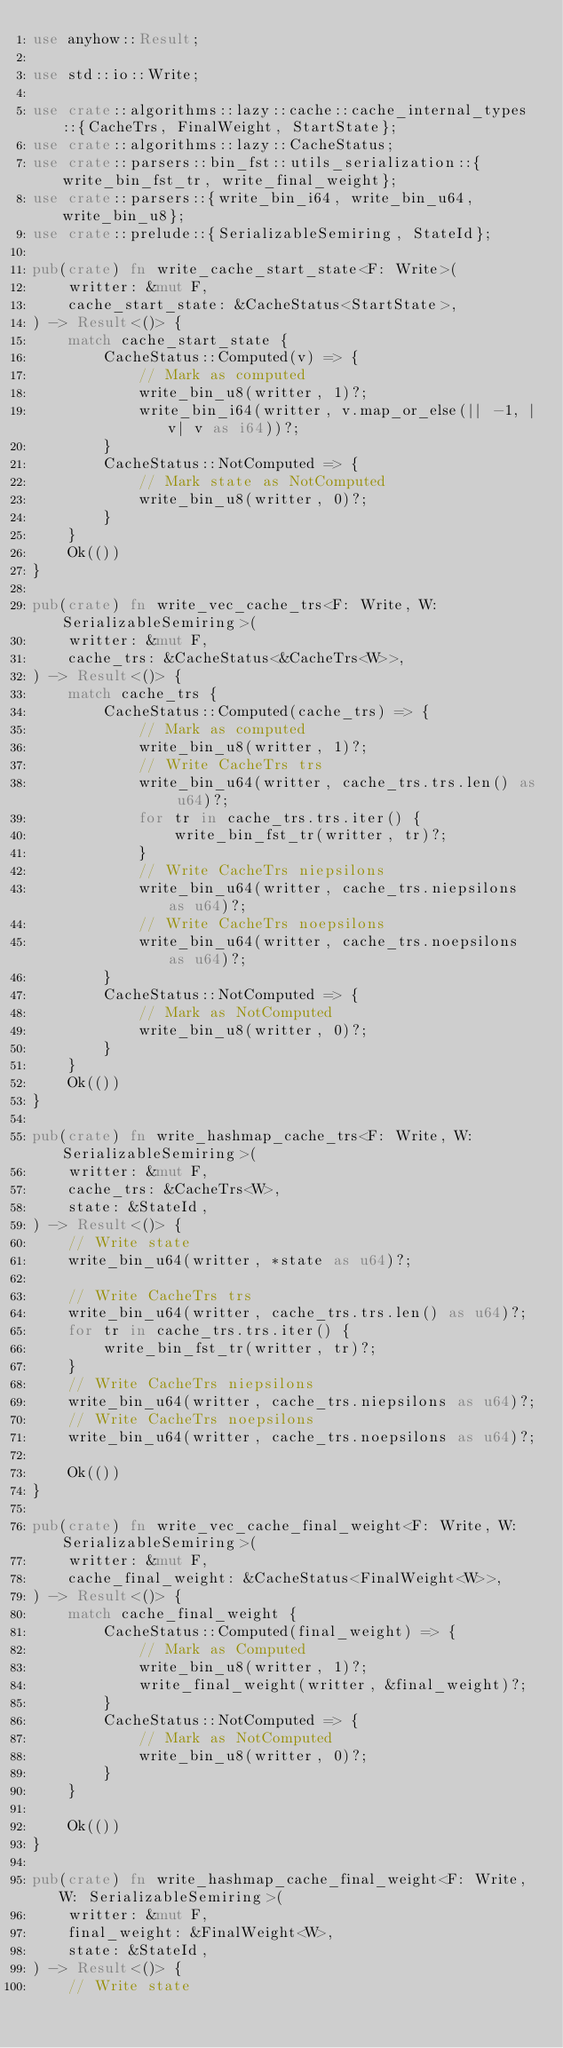<code> <loc_0><loc_0><loc_500><loc_500><_Rust_>use anyhow::Result;

use std::io::Write;

use crate::algorithms::lazy::cache::cache_internal_types::{CacheTrs, FinalWeight, StartState};
use crate::algorithms::lazy::CacheStatus;
use crate::parsers::bin_fst::utils_serialization::{write_bin_fst_tr, write_final_weight};
use crate::parsers::{write_bin_i64, write_bin_u64, write_bin_u8};
use crate::prelude::{SerializableSemiring, StateId};

pub(crate) fn write_cache_start_state<F: Write>(
    writter: &mut F,
    cache_start_state: &CacheStatus<StartState>,
) -> Result<()> {
    match cache_start_state {
        CacheStatus::Computed(v) => {
            // Mark as computed
            write_bin_u8(writter, 1)?;
            write_bin_i64(writter, v.map_or_else(|| -1, |v| v as i64))?;
        }
        CacheStatus::NotComputed => {
            // Mark state as NotComputed
            write_bin_u8(writter, 0)?;
        }
    }
    Ok(())
}

pub(crate) fn write_vec_cache_trs<F: Write, W: SerializableSemiring>(
    writter: &mut F,
    cache_trs: &CacheStatus<&CacheTrs<W>>,
) -> Result<()> {
    match cache_trs {
        CacheStatus::Computed(cache_trs) => {
            // Mark as computed
            write_bin_u8(writter, 1)?;
            // Write CacheTrs trs
            write_bin_u64(writter, cache_trs.trs.len() as u64)?;
            for tr in cache_trs.trs.iter() {
                write_bin_fst_tr(writter, tr)?;
            }
            // Write CacheTrs niepsilons
            write_bin_u64(writter, cache_trs.niepsilons as u64)?;
            // Write CacheTrs noepsilons
            write_bin_u64(writter, cache_trs.noepsilons as u64)?;
        }
        CacheStatus::NotComputed => {
            // Mark as NotComputed
            write_bin_u8(writter, 0)?;
        }
    }
    Ok(())
}

pub(crate) fn write_hashmap_cache_trs<F: Write, W: SerializableSemiring>(
    writter: &mut F,
    cache_trs: &CacheTrs<W>,
    state: &StateId,
) -> Result<()> {
    // Write state
    write_bin_u64(writter, *state as u64)?;

    // Write CacheTrs trs
    write_bin_u64(writter, cache_trs.trs.len() as u64)?;
    for tr in cache_trs.trs.iter() {
        write_bin_fst_tr(writter, tr)?;
    }
    // Write CacheTrs niepsilons
    write_bin_u64(writter, cache_trs.niepsilons as u64)?;
    // Write CacheTrs noepsilons
    write_bin_u64(writter, cache_trs.noepsilons as u64)?;

    Ok(())
}

pub(crate) fn write_vec_cache_final_weight<F: Write, W: SerializableSemiring>(
    writter: &mut F,
    cache_final_weight: &CacheStatus<FinalWeight<W>>,
) -> Result<()> {
    match cache_final_weight {
        CacheStatus::Computed(final_weight) => {
            // Mark as Computed
            write_bin_u8(writter, 1)?;
            write_final_weight(writter, &final_weight)?;
        }
        CacheStatus::NotComputed => {
            // Mark as NotComputed
            write_bin_u8(writter, 0)?;
        }
    }

    Ok(())
}

pub(crate) fn write_hashmap_cache_final_weight<F: Write, W: SerializableSemiring>(
    writter: &mut F,
    final_weight: &FinalWeight<W>,
    state: &StateId,
) -> Result<()> {
    // Write state</code> 